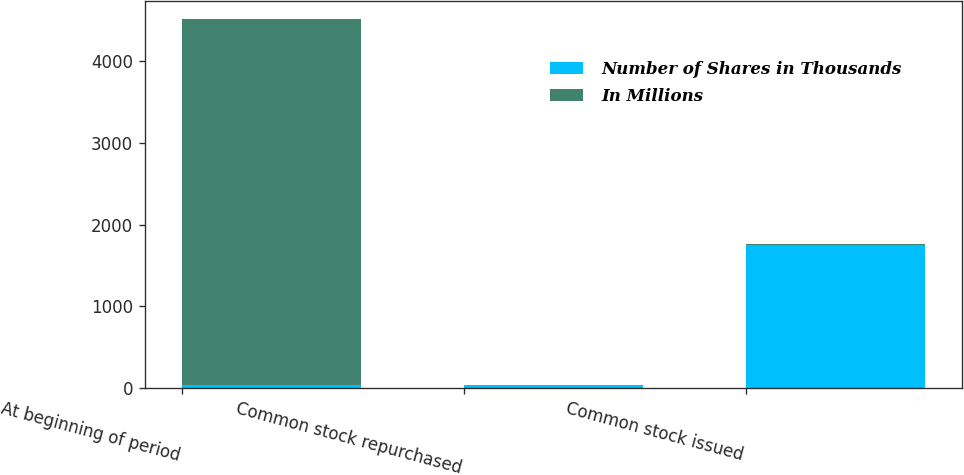<chart> <loc_0><loc_0><loc_500><loc_500><stacked_bar_chart><ecel><fcel>At beginning of period<fcel>Common stock repurchased<fcel>Common stock issued<nl><fcel>Number of Shares in Thousands<fcel>38<fcel>38<fcel>1751<nl><fcel>In Millions<fcel>4480<fcel>1<fcel>17<nl></chart> 